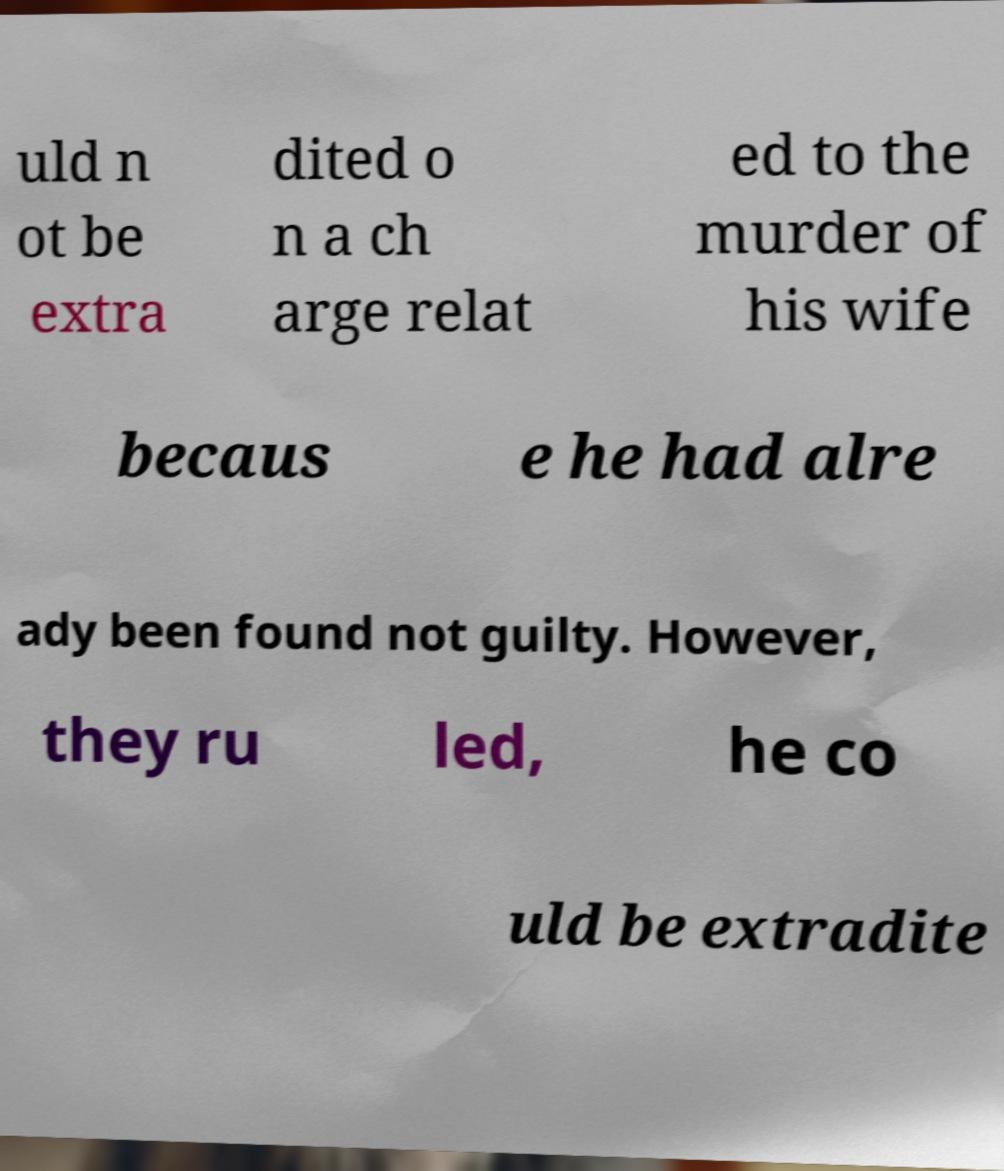I need the written content from this picture converted into text. Can you do that? uld n ot be extra dited o n a ch arge relat ed to the murder of his wife becaus e he had alre ady been found not guilty. However, they ru led, he co uld be extradite 